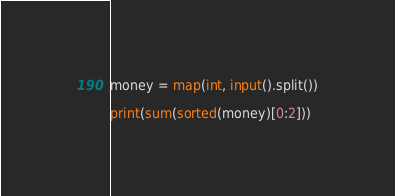Convert code to text. <code><loc_0><loc_0><loc_500><loc_500><_Python_>money = map(int, input().split())

print(sum(sorted(money)[0:2]))
</code> 